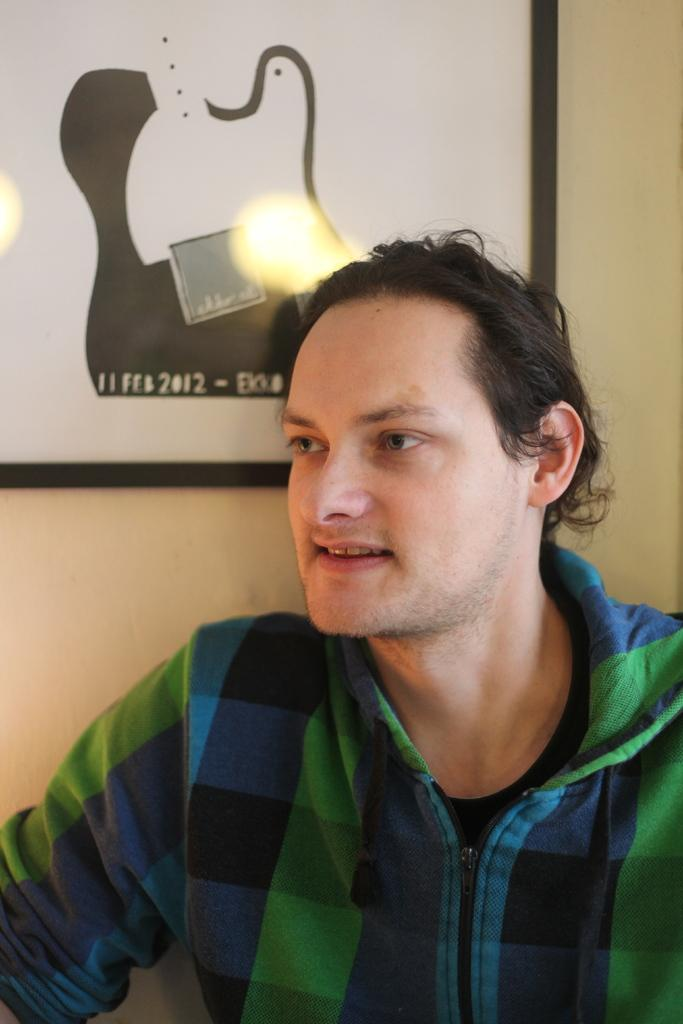What is present in the image? There is a person and a frame on the wall in the image. Can you describe the frame on the wall? The frame is on the wall, but no specific details about its appearance or content are provided. What is the person in the image doing? The provided facts do not specify any actions or activities of the person in the image. What type of kite is the person flying in the image? There is no kite present in the image; it only features a person and a frame on the wall. What kind of produce is the person tasting in the image? There is no produce or tasting activity depicted in the image. 